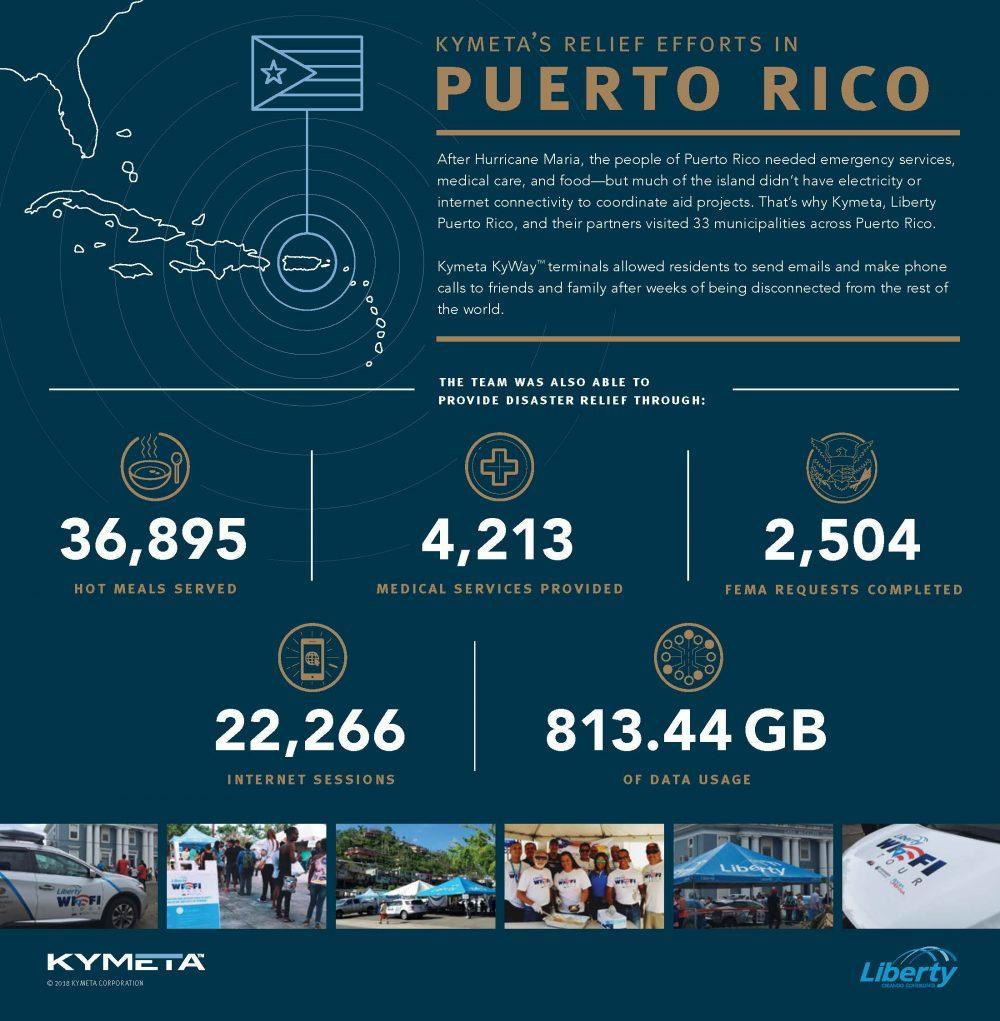How much data usage was enabled by the relief team?
Answer the question with a short phrase. 813.44 GB The names of which two companies are mentioned? Kymeta, Liberty How many medical services were provided by the relief team? 4,213 How many FEMA requests were completed? 2,504 How many internet sessions were enabled? 22,266 How many hot meals were served? 36,895 